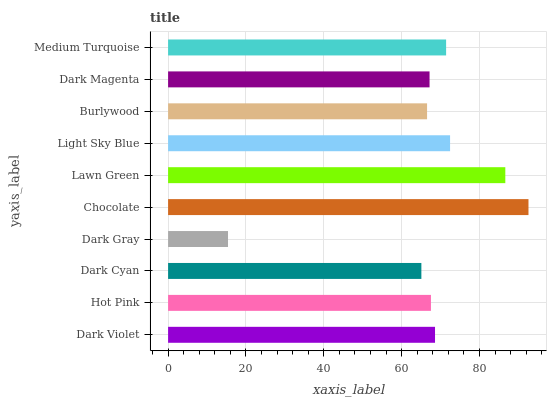Is Dark Gray the minimum?
Answer yes or no. Yes. Is Chocolate the maximum?
Answer yes or no. Yes. Is Hot Pink the minimum?
Answer yes or no. No. Is Hot Pink the maximum?
Answer yes or no. No. Is Dark Violet greater than Hot Pink?
Answer yes or no. Yes. Is Hot Pink less than Dark Violet?
Answer yes or no. Yes. Is Hot Pink greater than Dark Violet?
Answer yes or no. No. Is Dark Violet less than Hot Pink?
Answer yes or no. No. Is Dark Violet the high median?
Answer yes or no. Yes. Is Hot Pink the low median?
Answer yes or no. Yes. Is Burlywood the high median?
Answer yes or no. No. Is Dark Cyan the low median?
Answer yes or no. No. 